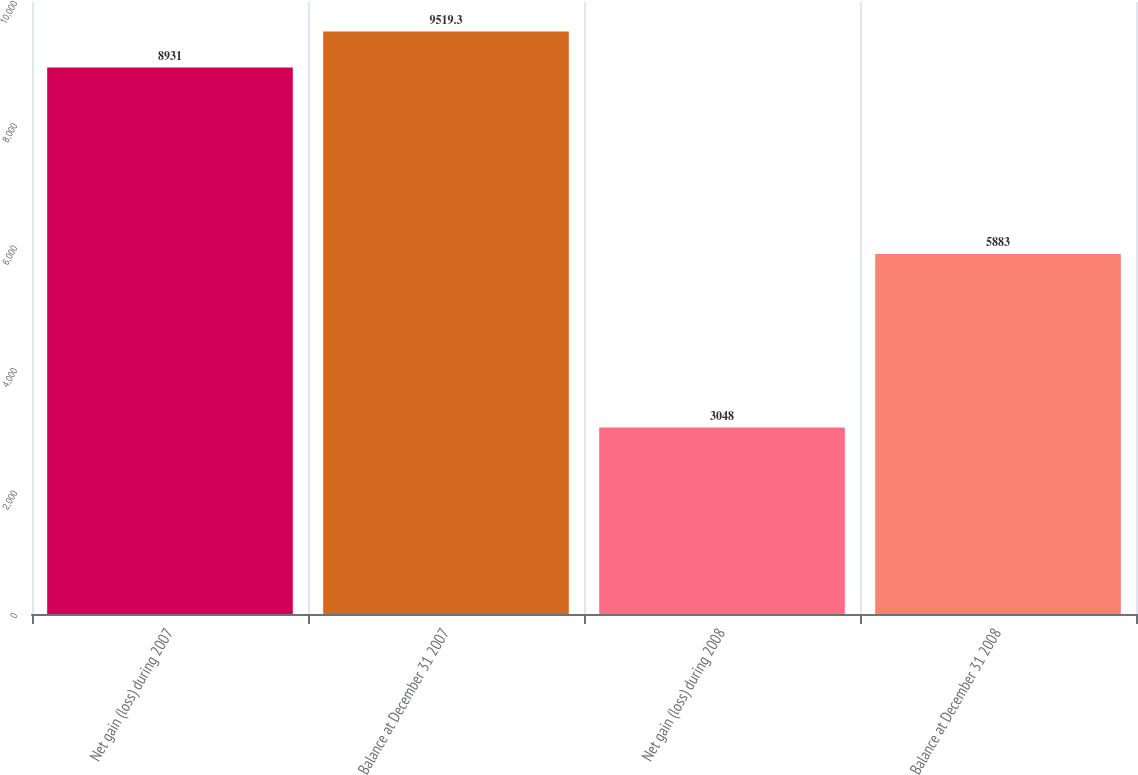Convert chart to OTSL. <chart><loc_0><loc_0><loc_500><loc_500><bar_chart><fcel>Net gain (loss) during 2007<fcel>Balance at December 31 2007<fcel>Net gain (loss) during 2008<fcel>Balance at December 31 2008<nl><fcel>8931<fcel>9519.3<fcel>3048<fcel>5883<nl></chart> 